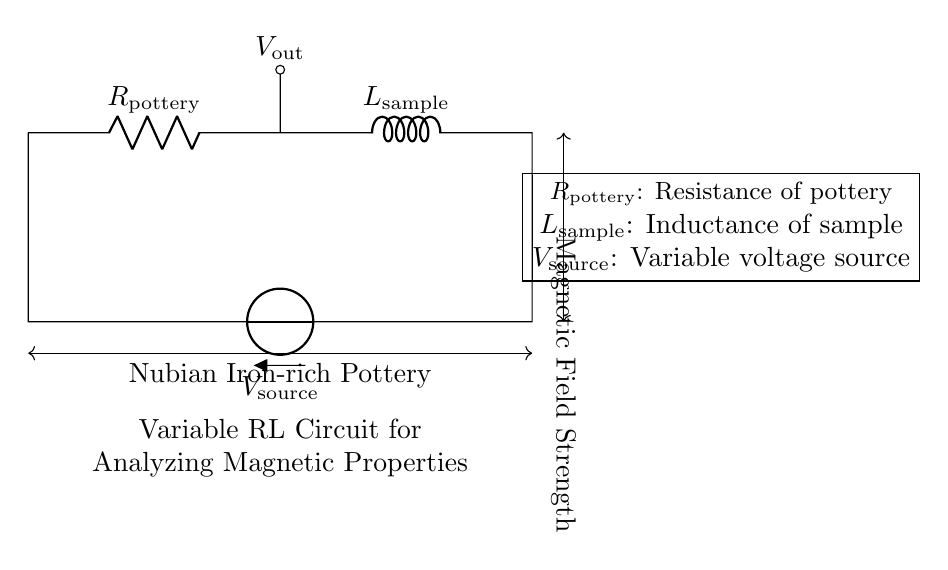What type of circuit is this? The circuit is a variable RL circuit, which includes a resistor and an inductor. The presence of both components signifies that it is an RL circuit.
Answer: variable RL circuit What does R represent in the circuit? R represents the resistance of the pottery, which is the resistance value associated with the material being tested from Nubian excavation sites.
Answer: resistance of pottery What is the role of V in the circuit? V represents the variable voltage source, supplying power to the circuit and allowing the adjustment of current for analysis.
Answer: variable voltage source How does the inductance L influence the circuit behavior? The inductance L influences how the circuit responds to changes in voltage, affecting the magnetic properties being studied in the iron-rich pottery. Inductance measures how much the current changes in response to a voltage change over time.
Answer: affects current response What is being analyzed with this circuit? The circuit is being used to analyze the magnetic properties of iron-rich pottery found at Nubian excavation sites, focusing on the material's resistance and inductance.
Answer: magnetic properties of pottery What type of connection is at the bottom of the circuit? The bottom of the circuit shows a short connection that completes the circuit loop, allowing current to flow from the voltage source through the resistive and inductive components.
Answer: short connection 